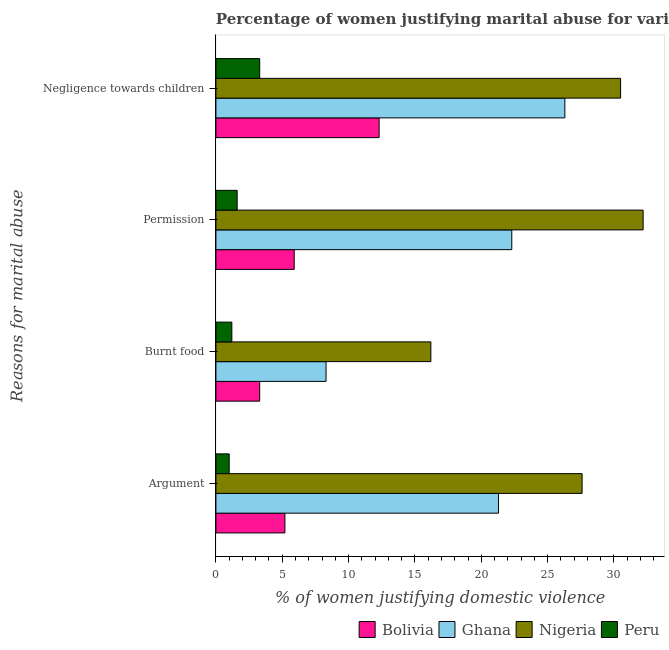How many different coloured bars are there?
Provide a succinct answer. 4. How many groups of bars are there?
Provide a short and direct response. 4. Are the number of bars on each tick of the Y-axis equal?
Your response must be concise. Yes. How many bars are there on the 1st tick from the top?
Offer a very short reply. 4. How many bars are there on the 4th tick from the bottom?
Your answer should be compact. 4. What is the label of the 4th group of bars from the top?
Your response must be concise. Argument. What is the percentage of women justifying abuse in the case of an argument in Bolivia?
Give a very brief answer. 5.2. Across all countries, what is the maximum percentage of women justifying abuse for going without permission?
Give a very brief answer. 32.2. Across all countries, what is the minimum percentage of women justifying abuse for burning food?
Make the answer very short. 1.2. In which country was the percentage of women justifying abuse for burning food maximum?
Offer a terse response. Nigeria. What is the total percentage of women justifying abuse in the case of an argument in the graph?
Your answer should be compact. 55.1. What is the difference between the percentage of women justifying abuse for showing negligence towards children in Nigeria and the percentage of women justifying abuse for going without permission in Peru?
Your answer should be compact. 28.9. What is the average percentage of women justifying abuse for burning food per country?
Ensure brevity in your answer.  7.25. What is the difference between the percentage of women justifying abuse for burning food and percentage of women justifying abuse for showing negligence towards children in Peru?
Your answer should be very brief. -2.1. What is the ratio of the percentage of women justifying abuse for showing negligence towards children in Nigeria to that in Ghana?
Your answer should be compact. 1.16. Is the percentage of women justifying abuse for going without permission in Nigeria less than that in Ghana?
Offer a terse response. No. What is the difference between the highest and the second highest percentage of women justifying abuse for going without permission?
Your response must be concise. 9.9. What is the difference between the highest and the lowest percentage of women justifying abuse for burning food?
Provide a short and direct response. 15. In how many countries, is the percentage of women justifying abuse in the case of an argument greater than the average percentage of women justifying abuse in the case of an argument taken over all countries?
Your answer should be compact. 2. Is the sum of the percentage of women justifying abuse in the case of an argument in Peru and Ghana greater than the maximum percentage of women justifying abuse for burning food across all countries?
Offer a terse response. Yes. Are all the bars in the graph horizontal?
Provide a short and direct response. Yes. Does the graph contain any zero values?
Ensure brevity in your answer.  No. Does the graph contain grids?
Offer a very short reply. No. How many legend labels are there?
Provide a succinct answer. 4. What is the title of the graph?
Provide a short and direct response. Percentage of women justifying marital abuse for various reasons in the survey of 2008. What is the label or title of the X-axis?
Make the answer very short. % of women justifying domestic violence. What is the label or title of the Y-axis?
Give a very brief answer. Reasons for marital abuse. What is the % of women justifying domestic violence of Bolivia in Argument?
Keep it short and to the point. 5.2. What is the % of women justifying domestic violence in Ghana in Argument?
Your answer should be compact. 21.3. What is the % of women justifying domestic violence of Nigeria in Argument?
Ensure brevity in your answer.  27.6. What is the % of women justifying domestic violence in Peru in Argument?
Offer a very short reply. 1. What is the % of women justifying domestic violence of Peru in Burnt food?
Your response must be concise. 1.2. What is the % of women justifying domestic violence in Bolivia in Permission?
Ensure brevity in your answer.  5.9. What is the % of women justifying domestic violence of Ghana in Permission?
Your response must be concise. 22.3. What is the % of women justifying domestic violence of Nigeria in Permission?
Your answer should be compact. 32.2. What is the % of women justifying domestic violence of Bolivia in Negligence towards children?
Provide a short and direct response. 12.3. What is the % of women justifying domestic violence of Ghana in Negligence towards children?
Keep it short and to the point. 26.3. What is the % of women justifying domestic violence in Nigeria in Negligence towards children?
Provide a short and direct response. 30.5. Across all Reasons for marital abuse, what is the maximum % of women justifying domestic violence of Ghana?
Offer a very short reply. 26.3. Across all Reasons for marital abuse, what is the maximum % of women justifying domestic violence in Nigeria?
Your answer should be compact. 32.2. Across all Reasons for marital abuse, what is the minimum % of women justifying domestic violence in Bolivia?
Make the answer very short. 3.3. Across all Reasons for marital abuse, what is the minimum % of women justifying domestic violence of Ghana?
Offer a very short reply. 8.3. Across all Reasons for marital abuse, what is the minimum % of women justifying domestic violence in Peru?
Offer a terse response. 1. What is the total % of women justifying domestic violence in Bolivia in the graph?
Your answer should be compact. 26.7. What is the total % of women justifying domestic violence in Ghana in the graph?
Give a very brief answer. 78.2. What is the total % of women justifying domestic violence of Nigeria in the graph?
Give a very brief answer. 106.5. What is the total % of women justifying domestic violence in Peru in the graph?
Make the answer very short. 7.1. What is the difference between the % of women justifying domestic violence in Ghana in Argument and that in Burnt food?
Your response must be concise. 13. What is the difference between the % of women justifying domestic violence of Bolivia in Argument and that in Permission?
Offer a terse response. -0.7. What is the difference between the % of women justifying domestic violence of Ghana in Argument and that in Permission?
Provide a succinct answer. -1. What is the difference between the % of women justifying domestic violence in Bolivia in Argument and that in Negligence towards children?
Provide a short and direct response. -7.1. What is the difference between the % of women justifying domestic violence of Nigeria in Argument and that in Negligence towards children?
Ensure brevity in your answer.  -2.9. What is the difference between the % of women justifying domestic violence of Peru in Argument and that in Negligence towards children?
Ensure brevity in your answer.  -2.3. What is the difference between the % of women justifying domestic violence of Nigeria in Burnt food and that in Permission?
Make the answer very short. -16. What is the difference between the % of women justifying domestic violence of Peru in Burnt food and that in Permission?
Give a very brief answer. -0.4. What is the difference between the % of women justifying domestic violence in Bolivia in Burnt food and that in Negligence towards children?
Your response must be concise. -9. What is the difference between the % of women justifying domestic violence in Nigeria in Burnt food and that in Negligence towards children?
Offer a terse response. -14.3. What is the difference between the % of women justifying domestic violence in Ghana in Permission and that in Negligence towards children?
Give a very brief answer. -4. What is the difference between the % of women justifying domestic violence of Peru in Permission and that in Negligence towards children?
Make the answer very short. -1.7. What is the difference between the % of women justifying domestic violence in Bolivia in Argument and the % of women justifying domestic violence in Ghana in Burnt food?
Your answer should be compact. -3.1. What is the difference between the % of women justifying domestic violence in Ghana in Argument and the % of women justifying domestic violence in Peru in Burnt food?
Make the answer very short. 20.1. What is the difference between the % of women justifying domestic violence in Nigeria in Argument and the % of women justifying domestic violence in Peru in Burnt food?
Give a very brief answer. 26.4. What is the difference between the % of women justifying domestic violence in Bolivia in Argument and the % of women justifying domestic violence in Ghana in Permission?
Keep it short and to the point. -17.1. What is the difference between the % of women justifying domestic violence of Bolivia in Argument and the % of women justifying domestic violence of Nigeria in Permission?
Give a very brief answer. -27. What is the difference between the % of women justifying domestic violence in Ghana in Argument and the % of women justifying domestic violence in Nigeria in Permission?
Ensure brevity in your answer.  -10.9. What is the difference between the % of women justifying domestic violence of Nigeria in Argument and the % of women justifying domestic violence of Peru in Permission?
Provide a short and direct response. 26. What is the difference between the % of women justifying domestic violence in Bolivia in Argument and the % of women justifying domestic violence in Ghana in Negligence towards children?
Your response must be concise. -21.1. What is the difference between the % of women justifying domestic violence of Bolivia in Argument and the % of women justifying domestic violence of Nigeria in Negligence towards children?
Make the answer very short. -25.3. What is the difference between the % of women justifying domestic violence of Ghana in Argument and the % of women justifying domestic violence of Nigeria in Negligence towards children?
Your answer should be very brief. -9.2. What is the difference between the % of women justifying domestic violence in Nigeria in Argument and the % of women justifying domestic violence in Peru in Negligence towards children?
Your answer should be compact. 24.3. What is the difference between the % of women justifying domestic violence of Bolivia in Burnt food and the % of women justifying domestic violence of Ghana in Permission?
Your answer should be compact. -19. What is the difference between the % of women justifying domestic violence of Bolivia in Burnt food and the % of women justifying domestic violence of Nigeria in Permission?
Keep it short and to the point. -28.9. What is the difference between the % of women justifying domestic violence in Bolivia in Burnt food and the % of women justifying domestic violence in Peru in Permission?
Keep it short and to the point. 1.7. What is the difference between the % of women justifying domestic violence in Ghana in Burnt food and the % of women justifying domestic violence in Nigeria in Permission?
Provide a succinct answer. -23.9. What is the difference between the % of women justifying domestic violence of Ghana in Burnt food and the % of women justifying domestic violence of Peru in Permission?
Make the answer very short. 6.7. What is the difference between the % of women justifying domestic violence of Nigeria in Burnt food and the % of women justifying domestic violence of Peru in Permission?
Keep it short and to the point. 14.6. What is the difference between the % of women justifying domestic violence of Bolivia in Burnt food and the % of women justifying domestic violence of Nigeria in Negligence towards children?
Your answer should be very brief. -27.2. What is the difference between the % of women justifying domestic violence of Ghana in Burnt food and the % of women justifying domestic violence of Nigeria in Negligence towards children?
Your answer should be very brief. -22.2. What is the difference between the % of women justifying domestic violence of Bolivia in Permission and the % of women justifying domestic violence of Ghana in Negligence towards children?
Give a very brief answer. -20.4. What is the difference between the % of women justifying domestic violence in Bolivia in Permission and the % of women justifying domestic violence in Nigeria in Negligence towards children?
Provide a succinct answer. -24.6. What is the difference between the % of women justifying domestic violence in Ghana in Permission and the % of women justifying domestic violence in Peru in Negligence towards children?
Offer a very short reply. 19. What is the difference between the % of women justifying domestic violence in Nigeria in Permission and the % of women justifying domestic violence in Peru in Negligence towards children?
Provide a succinct answer. 28.9. What is the average % of women justifying domestic violence in Bolivia per Reasons for marital abuse?
Ensure brevity in your answer.  6.67. What is the average % of women justifying domestic violence of Ghana per Reasons for marital abuse?
Make the answer very short. 19.55. What is the average % of women justifying domestic violence in Nigeria per Reasons for marital abuse?
Make the answer very short. 26.62. What is the average % of women justifying domestic violence in Peru per Reasons for marital abuse?
Offer a very short reply. 1.77. What is the difference between the % of women justifying domestic violence in Bolivia and % of women justifying domestic violence in Ghana in Argument?
Ensure brevity in your answer.  -16.1. What is the difference between the % of women justifying domestic violence in Bolivia and % of women justifying domestic violence in Nigeria in Argument?
Your answer should be compact. -22.4. What is the difference between the % of women justifying domestic violence in Ghana and % of women justifying domestic violence in Peru in Argument?
Make the answer very short. 20.3. What is the difference between the % of women justifying domestic violence of Nigeria and % of women justifying domestic violence of Peru in Argument?
Your answer should be very brief. 26.6. What is the difference between the % of women justifying domestic violence in Bolivia and % of women justifying domestic violence in Ghana in Burnt food?
Offer a very short reply. -5. What is the difference between the % of women justifying domestic violence in Ghana and % of women justifying domestic violence in Nigeria in Burnt food?
Provide a succinct answer. -7.9. What is the difference between the % of women justifying domestic violence of Nigeria and % of women justifying domestic violence of Peru in Burnt food?
Give a very brief answer. 15. What is the difference between the % of women justifying domestic violence in Bolivia and % of women justifying domestic violence in Ghana in Permission?
Give a very brief answer. -16.4. What is the difference between the % of women justifying domestic violence of Bolivia and % of women justifying domestic violence of Nigeria in Permission?
Your answer should be compact. -26.3. What is the difference between the % of women justifying domestic violence in Bolivia and % of women justifying domestic violence in Peru in Permission?
Give a very brief answer. 4.3. What is the difference between the % of women justifying domestic violence of Ghana and % of women justifying domestic violence of Nigeria in Permission?
Ensure brevity in your answer.  -9.9. What is the difference between the % of women justifying domestic violence in Ghana and % of women justifying domestic violence in Peru in Permission?
Make the answer very short. 20.7. What is the difference between the % of women justifying domestic violence in Nigeria and % of women justifying domestic violence in Peru in Permission?
Your answer should be very brief. 30.6. What is the difference between the % of women justifying domestic violence of Bolivia and % of women justifying domestic violence of Nigeria in Negligence towards children?
Provide a short and direct response. -18.2. What is the difference between the % of women justifying domestic violence in Nigeria and % of women justifying domestic violence in Peru in Negligence towards children?
Offer a terse response. 27.2. What is the ratio of the % of women justifying domestic violence of Bolivia in Argument to that in Burnt food?
Your response must be concise. 1.58. What is the ratio of the % of women justifying domestic violence in Ghana in Argument to that in Burnt food?
Give a very brief answer. 2.57. What is the ratio of the % of women justifying domestic violence in Nigeria in Argument to that in Burnt food?
Give a very brief answer. 1.7. What is the ratio of the % of women justifying domestic violence in Bolivia in Argument to that in Permission?
Give a very brief answer. 0.88. What is the ratio of the % of women justifying domestic violence of Ghana in Argument to that in Permission?
Provide a succinct answer. 0.96. What is the ratio of the % of women justifying domestic violence of Bolivia in Argument to that in Negligence towards children?
Provide a short and direct response. 0.42. What is the ratio of the % of women justifying domestic violence of Ghana in Argument to that in Negligence towards children?
Keep it short and to the point. 0.81. What is the ratio of the % of women justifying domestic violence of Nigeria in Argument to that in Negligence towards children?
Provide a short and direct response. 0.9. What is the ratio of the % of women justifying domestic violence of Peru in Argument to that in Negligence towards children?
Keep it short and to the point. 0.3. What is the ratio of the % of women justifying domestic violence of Bolivia in Burnt food to that in Permission?
Provide a short and direct response. 0.56. What is the ratio of the % of women justifying domestic violence of Ghana in Burnt food to that in Permission?
Provide a succinct answer. 0.37. What is the ratio of the % of women justifying domestic violence of Nigeria in Burnt food to that in Permission?
Offer a very short reply. 0.5. What is the ratio of the % of women justifying domestic violence of Peru in Burnt food to that in Permission?
Your answer should be very brief. 0.75. What is the ratio of the % of women justifying domestic violence of Bolivia in Burnt food to that in Negligence towards children?
Make the answer very short. 0.27. What is the ratio of the % of women justifying domestic violence of Ghana in Burnt food to that in Negligence towards children?
Keep it short and to the point. 0.32. What is the ratio of the % of women justifying domestic violence in Nigeria in Burnt food to that in Negligence towards children?
Offer a terse response. 0.53. What is the ratio of the % of women justifying domestic violence of Peru in Burnt food to that in Negligence towards children?
Your answer should be very brief. 0.36. What is the ratio of the % of women justifying domestic violence in Bolivia in Permission to that in Negligence towards children?
Your response must be concise. 0.48. What is the ratio of the % of women justifying domestic violence in Ghana in Permission to that in Negligence towards children?
Your answer should be compact. 0.85. What is the ratio of the % of women justifying domestic violence of Nigeria in Permission to that in Negligence towards children?
Your answer should be very brief. 1.06. What is the ratio of the % of women justifying domestic violence in Peru in Permission to that in Negligence towards children?
Keep it short and to the point. 0.48. What is the difference between the highest and the second highest % of women justifying domestic violence of Nigeria?
Your answer should be compact. 1.7. What is the difference between the highest and the second highest % of women justifying domestic violence of Peru?
Provide a succinct answer. 1.7. What is the difference between the highest and the lowest % of women justifying domestic violence of Bolivia?
Offer a terse response. 9. 